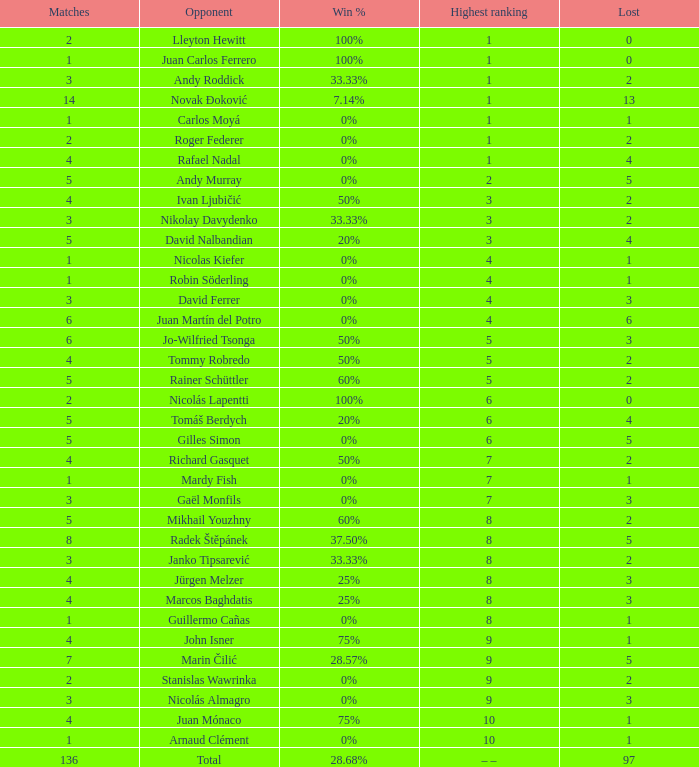What is the total number of Lost for the Highest Ranking of – –? 1.0. Could you help me parse every detail presented in this table? {'header': ['Matches', 'Opponent', 'Win %', 'Highest ranking', 'Lost'], 'rows': [['2', 'Lleyton Hewitt', '100%', '1', '0'], ['1', 'Juan Carlos Ferrero', '100%', '1', '0'], ['3', 'Andy Roddick', '33.33%', '1', '2'], ['14', 'Novak Đoković', '7.14%', '1', '13'], ['1', 'Carlos Moyá', '0%', '1', '1'], ['2', 'Roger Federer', '0%', '1', '2'], ['4', 'Rafael Nadal', '0%', '1', '4'], ['5', 'Andy Murray', '0%', '2', '5'], ['4', 'Ivan Ljubičić', '50%', '3', '2'], ['3', 'Nikolay Davydenko', '33.33%', '3', '2'], ['5', 'David Nalbandian', '20%', '3', '4'], ['1', 'Nicolas Kiefer', '0%', '4', '1'], ['1', 'Robin Söderling', '0%', '4', '1'], ['3', 'David Ferrer', '0%', '4', '3'], ['6', 'Juan Martín del Potro', '0%', '4', '6'], ['6', 'Jo-Wilfried Tsonga', '50%', '5', '3'], ['4', 'Tommy Robredo', '50%', '5', '2'], ['5', 'Rainer Schüttler', '60%', '5', '2'], ['2', 'Nicolás Lapentti', '100%', '6', '0'], ['5', 'Tomáš Berdych', '20%', '6', '4'], ['5', 'Gilles Simon', '0%', '6', '5'], ['4', 'Richard Gasquet', '50%', '7', '2'], ['1', 'Mardy Fish', '0%', '7', '1'], ['3', 'Gaël Monfils', '0%', '7', '3'], ['5', 'Mikhail Youzhny', '60%', '8', '2'], ['8', 'Radek Štěpánek', '37.50%', '8', '5'], ['3', 'Janko Tipsarević', '33.33%', '8', '2'], ['4', 'Jürgen Melzer', '25%', '8', '3'], ['4', 'Marcos Baghdatis', '25%', '8', '3'], ['1', 'Guillermo Cañas', '0%', '8', '1'], ['4', 'John Isner', '75%', '9', '1'], ['7', 'Marin Čilić', '28.57%', '9', '5'], ['2', 'Stanislas Wawrinka', '0%', '9', '2'], ['3', 'Nicolás Almagro', '0%', '9', '3'], ['4', 'Juan Mónaco', '75%', '10', '1'], ['1', 'Arnaud Clément', '0%', '10', '1'], ['136', 'Total', '28.68%', '– –', '97']]} 